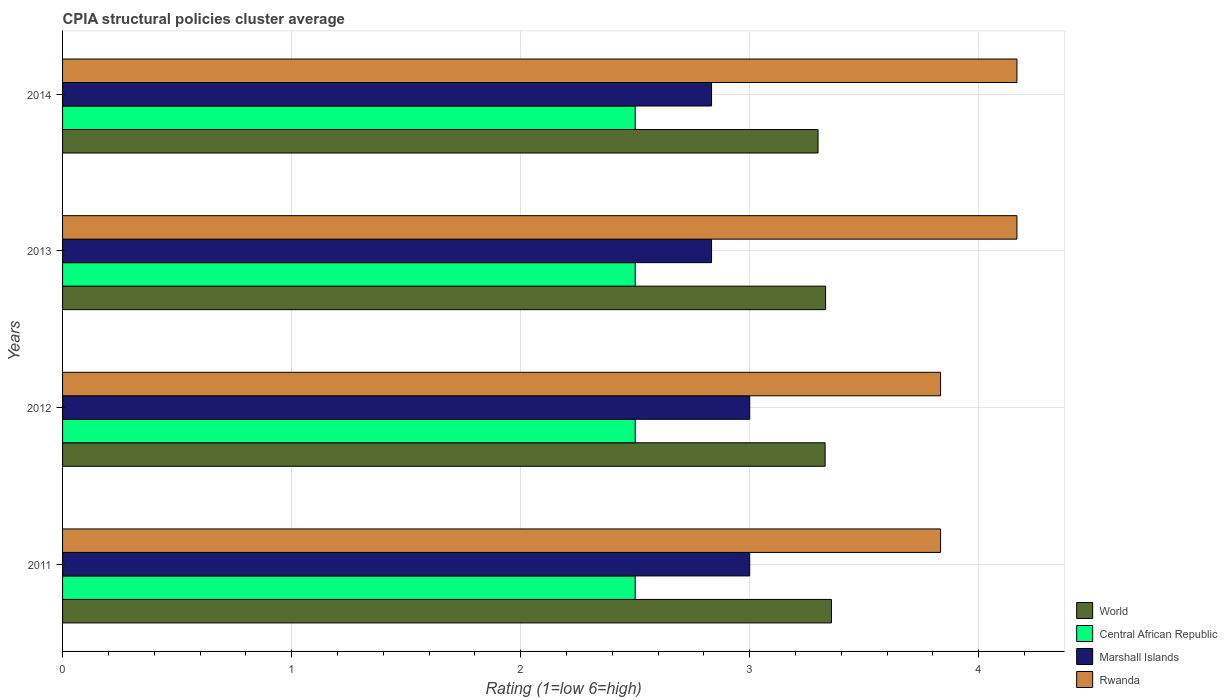How many different coloured bars are there?
Give a very brief answer. 4. How many groups of bars are there?
Offer a very short reply. 4. Are the number of bars per tick equal to the number of legend labels?
Your answer should be compact. Yes. How many bars are there on the 1st tick from the top?
Keep it short and to the point. 4. What is the label of the 3rd group of bars from the top?
Provide a succinct answer. 2012. In how many cases, is the number of bars for a given year not equal to the number of legend labels?
Offer a terse response. 0. What is the CPIA rating in Rwanda in 2012?
Give a very brief answer. 3.83. Across all years, what is the minimum CPIA rating in World?
Keep it short and to the point. 3.3. In which year was the CPIA rating in World maximum?
Your answer should be compact. 2011. What is the total CPIA rating in Central African Republic in the graph?
Your answer should be compact. 10. What is the difference between the CPIA rating in World in 2012 and that in 2014?
Keep it short and to the point. 0.03. What is the difference between the CPIA rating in Rwanda in 2014 and the CPIA rating in Marshall Islands in 2012?
Provide a succinct answer. 1.17. What is the average CPIA rating in World per year?
Your answer should be very brief. 3.33. In the year 2014, what is the difference between the CPIA rating in Rwanda and CPIA rating in Marshall Islands?
Offer a very short reply. 1.33. In how many years, is the CPIA rating in Central African Republic greater than 1.6 ?
Offer a very short reply. 4. What is the ratio of the CPIA rating in World in 2012 to that in 2013?
Ensure brevity in your answer.  1. What is the difference between the highest and the second highest CPIA rating in Marshall Islands?
Offer a terse response. 0. What is the difference between the highest and the lowest CPIA rating in Rwanda?
Offer a very short reply. 0.33. In how many years, is the CPIA rating in Central African Republic greater than the average CPIA rating in Central African Republic taken over all years?
Keep it short and to the point. 0. Is the sum of the CPIA rating in World in 2011 and 2014 greater than the maximum CPIA rating in Central African Republic across all years?
Keep it short and to the point. Yes. Is it the case that in every year, the sum of the CPIA rating in Rwanda and CPIA rating in Central African Republic is greater than the sum of CPIA rating in Marshall Islands and CPIA rating in World?
Make the answer very short. Yes. What does the 2nd bar from the top in 2012 represents?
Provide a succinct answer. Marshall Islands. What does the 2nd bar from the bottom in 2011 represents?
Make the answer very short. Central African Republic. Is it the case that in every year, the sum of the CPIA rating in Marshall Islands and CPIA rating in Rwanda is greater than the CPIA rating in World?
Your answer should be compact. Yes. How many bars are there?
Your response must be concise. 16. How many years are there in the graph?
Provide a succinct answer. 4. What is the difference between two consecutive major ticks on the X-axis?
Offer a terse response. 1. Are the values on the major ticks of X-axis written in scientific E-notation?
Provide a short and direct response. No. Where does the legend appear in the graph?
Your answer should be very brief. Bottom right. How many legend labels are there?
Your response must be concise. 4. How are the legend labels stacked?
Keep it short and to the point. Vertical. What is the title of the graph?
Keep it short and to the point. CPIA structural policies cluster average. What is the label or title of the X-axis?
Make the answer very short. Rating (1=low 6=high). What is the Rating (1=low 6=high) of World in 2011?
Offer a very short reply. 3.36. What is the Rating (1=low 6=high) in Central African Republic in 2011?
Ensure brevity in your answer.  2.5. What is the Rating (1=low 6=high) of Marshall Islands in 2011?
Offer a terse response. 3. What is the Rating (1=low 6=high) in Rwanda in 2011?
Ensure brevity in your answer.  3.83. What is the Rating (1=low 6=high) in World in 2012?
Your answer should be compact. 3.33. What is the Rating (1=low 6=high) in Central African Republic in 2012?
Provide a succinct answer. 2.5. What is the Rating (1=low 6=high) of Rwanda in 2012?
Keep it short and to the point. 3.83. What is the Rating (1=low 6=high) in World in 2013?
Offer a terse response. 3.33. What is the Rating (1=low 6=high) of Central African Republic in 2013?
Offer a very short reply. 2.5. What is the Rating (1=low 6=high) of Marshall Islands in 2013?
Give a very brief answer. 2.83. What is the Rating (1=low 6=high) in Rwanda in 2013?
Ensure brevity in your answer.  4.17. What is the Rating (1=low 6=high) of World in 2014?
Offer a very short reply. 3.3. What is the Rating (1=low 6=high) of Central African Republic in 2014?
Ensure brevity in your answer.  2.5. What is the Rating (1=low 6=high) in Marshall Islands in 2014?
Make the answer very short. 2.83. What is the Rating (1=low 6=high) in Rwanda in 2014?
Offer a very short reply. 4.17. Across all years, what is the maximum Rating (1=low 6=high) in World?
Provide a short and direct response. 3.36. Across all years, what is the maximum Rating (1=low 6=high) in Marshall Islands?
Your answer should be very brief. 3. Across all years, what is the maximum Rating (1=low 6=high) of Rwanda?
Make the answer very short. 4.17. Across all years, what is the minimum Rating (1=low 6=high) in World?
Provide a succinct answer. 3.3. Across all years, what is the minimum Rating (1=low 6=high) of Marshall Islands?
Provide a short and direct response. 2.83. Across all years, what is the minimum Rating (1=low 6=high) in Rwanda?
Make the answer very short. 3.83. What is the total Rating (1=low 6=high) in World in the graph?
Ensure brevity in your answer.  13.32. What is the total Rating (1=low 6=high) of Central African Republic in the graph?
Provide a short and direct response. 10. What is the total Rating (1=low 6=high) of Marshall Islands in the graph?
Keep it short and to the point. 11.67. What is the difference between the Rating (1=low 6=high) in World in 2011 and that in 2012?
Keep it short and to the point. 0.03. What is the difference between the Rating (1=low 6=high) in Marshall Islands in 2011 and that in 2012?
Ensure brevity in your answer.  0. What is the difference between the Rating (1=low 6=high) in Rwanda in 2011 and that in 2012?
Offer a terse response. 0. What is the difference between the Rating (1=low 6=high) in World in 2011 and that in 2013?
Offer a terse response. 0.03. What is the difference between the Rating (1=low 6=high) of Marshall Islands in 2011 and that in 2013?
Your response must be concise. 0.17. What is the difference between the Rating (1=low 6=high) of Rwanda in 2011 and that in 2013?
Give a very brief answer. -0.33. What is the difference between the Rating (1=low 6=high) of World in 2011 and that in 2014?
Keep it short and to the point. 0.06. What is the difference between the Rating (1=low 6=high) of Marshall Islands in 2011 and that in 2014?
Your answer should be very brief. 0.17. What is the difference between the Rating (1=low 6=high) of Rwanda in 2011 and that in 2014?
Provide a succinct answer. -0.33. What is the difference between the Rating (1=low 6=high) of World in 2012 and that in 2013?
Offer a terse response. -0. What is the difference between the Rating (1=low 6=high) of Central African Republic in 2012 and that in 2013?
Your answer should be compact. 0. What is the difference between the Rating (1=low 6=high) of Marshall Islands in 2012 and that in 2013?
Your answer should be compact. 0.17. What is the difference between the Rating (1=low 6=high) of World in 2012 and that in 2014?
Your answer should be very brief. 0.03. What is the difference between the Rating (1=low 6=high) of Marshall Islands in 2012 and that in 2014?
Ensure brevity in your answer.  0.17. What is the difference between the Rating (1=low 6=high) of World in 2013 and that in 2014?
Offer a very short reply. 0.03. What is the difference between the Rating (1=low 6=high) in Rwanda in 2013 and that in 2014?
Keep it short and to the point. -0. What is the difference between the Rating (1=low 6=high) in World in 2011 and the Rating (1=low 6=high) in Central African Republic in 2012?
Offer a terse response. 0.86. What is the difference between the Rating (1=low 6=high) of World in 2011 and the Rating (1=low 6=high) of Marshall Islands in 2012?
Ensure brevity in your answer.  0.36. What is the difference between the Rating (1=low 6=high) in World in 2011 and the Rating (1=low 6=high) in Rwanda in 2012?
Your answer should be very brief. -0.48. What is the difference between the Rating (1=low 6=high) in Central African Republic in 2011 and the Rating (1=low 6=high) in Marshall Islands in 2012?
Offer a terse response. -0.5. What is the difference between the Rating (1=low 6=high) in Central African Republic in 2011 and the Rating (1=low 6=high) in Rwanda in 2012?
Give a very brief answer. -1.33. What is the difference between the Rating (1=low 6=high) in World in 2011 and the Rating (1=low 6=high) in Central African Republic in 2013?
Give a very brief answer. 0.86. What is the difference between the Rating (1=low 6=high) of World in 2011 and the Rating (1=low 6=high) of Marshall Islands in 2013?
Your answer should be very brief. 0.52. What is the difference between the Rating (1=low 6=high) in World in 2011 and the Rating (1=low 6=high) in Rwanda in 2013?
Keep it short and to the point. -0.81. What is the difference between the Rating (1=low 6=high) in Central African Republic in 2011 and the Rating (1=low 6=high) in Rwanda in 2013?
Provide a short and direct response. -1.67. What is the difference between the Rating (1=low 6=high) in Marshall Islands in 2011 and the Rating (1=low 6=high) in Rwanda in 2013?
Ensure brevity in your answer.  -1.17. What is the difference between the Rating (1=low 6=high) in World in 2011 and the Rating (1=low 6=high) in Central African Republic in 2014?
Offer a terse response. 0.86. What is the difference between the Rating (1=low 6=high) of World in 2011 and the Rating (1=low 6=high) of Marshall Islands in 2014?
Make the answer very short. 0.52. What is the difference between the Rating (1=low 6=high) in World in 2011 and the Rating (1=low 6=high) in Rwanda in 2014?
Your response must be concise. -0.81. What is the difference between the Rating (1=low 6=high) of Central African Republic in 2011 and the Rating (1=low 6=high) of Marshall Islands in 2014?
Your response must be concise. -0.33. What is the difference between the Rating (1=low 6=high) of Central African Republic in 2011 and the Rating (1=low 6=high) of Rwanda in 2014?
Offer a terse response. -1.67. What is the difference between the Rating (1=low 6=high) of Marshall Islands in 2011 and the Rating (1=low 6=high) of Rwanda in 2014?
Provide a short and direct response. -1.17. What is the difference between the Rating (1=low 6=high) of World in 2012 and the Rating (1=low 6=high) of Central African Republic in 2013?
Keep it short and to the point. 0.83. What is the difference between the Rating (1=low 6=high) in World in 2012 and the Rating (1=low 6=high) in Marshall Islands in 2013?
Your response must be concise. 0.5. What is the difference between the Rating (1=low 6=high) of World in 2012 and the Rating (1=low 6=high) of Rwanda in 2013?
Keep it short and to the point. -0.84. What is the difference between the Rating (1=low 6=high) in Central African Republic in 2012 and the Rating (1=low 6=high) in Marshall Islands in 2013?
Make the answer very short. -0.33. What is the difference between the Rating (1=low 6=high) in Central African Republic in 2012 and the Rating (1=low 6=high) in Rwanda in 2013?
Keep it short and to the point. -1.67. What is the difference between the Rating (1=low 6=high) of Marshall Islands in 2012 and the Rating (1=low 6=high) of Rwanda in 2013?
Offer a terse response. -1.17. What is the difference between the Rating (1=low 6=high) of World in 2012 and the Rating (1=low 6=high) of Central African Republic in 2014?
Keep it short and to the point. 0.83. What is the difference between the Rating (1=low 6=high) of World in 2012 and the Rating (1=low 6=high) of Marshall Islands in 2014?
Your response must be concise. 0.5. What is the difference between the Rating (1=low 6=high) in World in 2012 and the Rating (1=low 6=high) in Rwanda in 2014?
Your response must be concise. -0.84. What is the difference between the Rating (1=low 6=high) of Central African Republic in 2012 and the Rating (1=low 6=high) of Rwanda in 2014?
Offer a terse response. -1.67. What is the difference between the Rating (1=low 6=high) of Marshall Islands in 2012 and the Rating (1=low 6=high) of Rwanda in 2014?
Your answer should be very brief. -1.17. What is the difference between the Rating (1=low 6=high) of World in 2013 and the Rating (1=low 6=high) of Central African Republic in 2014?
Ensure brevity in your answer.  0.83. What is the difference between the Rating (1=low 6=high) in World in 2013 and the Rating (1=low 6=high) in Marshall Islands in 2014?
Provide a short and direct response. 0.5. What is the difference between the Rating (1=low 6=high) of World in 2013 and the Rating (1=low 6=high) of Rwanda in 2014?
Your response must be concise. -0.84. What is the difference between the Rating (1=low 6=high) of Central African Republic in 2013 and the Rating (1=low 6=high) of Rwanda in 2014?
Your response must be concise. -1.67. What is the difference between the Rating (1=low 6=high) in Marshall Islands in 2013 and the Rating (1=low 6=high) in Rwanda in 2014?
Ensure brevity in your answer.  -1.33. What is the average Rating (1=low 6=high) of World per year?
Keep it short and to the point. 3.33. What is the average Rating (1=low 6=high) of Marshall Islands per year?
Your response must be concise. 2.92. In the year 2011, what is the difference between the Rating (1=low 6=high) of World and Rating (1=low 6=high) of Central African Republic?
Offer a terse response. 0.86. In the year 2011, what is the difference between the Rating (1=low 6=high) in World and Rating (1=low 6=high) in Marshall Islands?
Offer a very short reply. 0.36. In the year 2011, what is the difference between the Rating (1=low 6=high) of World and Rating (1=low 6=high) of Rwanda?
Offer a very short reply. -0.48. In the year 2011, what is the difference between the Rating (1=low 6=high) in Central African Republic and Rating (1=low 6=high) in Rwanda?
Make the answer very short. -1.33. In the year 2012, what is the difference between the Rating (1=low 6=high) in World and Rating (1=low 6=high) in Central African Republic?
Offer a terse response. 0.83. In the year 2012, what is the difference between the Rating (1=low 6=high) in World and Rating (1=low 6=high) in Marshall Islands?
Your answer should be very brief. 0.33. In the year 2012, what is the difference between the Rating (1=low 6=high) in World and Rating (1=low 6=high) in Rwanda?
Provide a succinct answer. -0.5. In the year 2012, what is the difference between the Rating (1=low 6=high) of Central African Republic and Rating (1=low 6=high) of Marshall Islands?
Offer a terse response. -0.5. In the year 2012, what is the difference between the Rating (1=low 6=high) in Central African Republic and Rating (1=low 6=high) in Rwanda?
Your response must be concise. -1.33. In the year 2013, what is the difference between the Rating (1=low 6=high) in World and Rating (1=low 6=high) in Central African Republic?
Keep it short and to the point. 0.83. In the year 2013, what is the difference between the Rating (1=low 6=high) in World and Rating (1=low 6=high) in Marshall Islands?
Provide a succinct answer. 0.5. In the year 2013, what is the difference between the Rating (1=low 6=high) in World and Rating (1=low 6=high) in Rwanda?
Provide a succinct answer. -0.84. In the year 2013, what is the difference between the Rating (1=low 6=high) in Central African Republic and Rating (1=low 6=high) in Marshall Islands?
Provide a succinct answer. -0.33. In the year 2013, what is the difference between the Rating (1=low 6=high) in Central African Republic and Rating (1=low 6=high) in Rwanda?
Ensure brevity in your answer.  -1.67. In the year 2013, what is the difference between the Rating (1=low 6=high) of Marshall Islands and Rating (1=low 6=high) of Rwanda?
Your answer should be very brief. -1.33. In the year 2014, what is the difference between the Rating (1=low 6=high) of World and Rating (1=low 6=high) of Central African Republic?
Provide a succinct answer. 0.8. In the year 2014, what is the difference between the Rating (1=low 6=high) of World and Rating (1=low 6=high) of Marshall Islands?
Your answer should be compact. 0.46. In the year 2014, what is the difference between the Rating (1=low 6=high) in World and Rating (1=low 6=high) in Rwanda?
Give a very brief answer. -0.87. In the year 2014, what is the difference between the Rating (1=low 6=high) of Central African Republic and Rating (1=low 6=high) of Marshall Islands?
Make the answer very short. -0.33. In the year 2014, what is the difference between the Rating (1=low 6=high) in Central African Republic and Rating (1=low 6=high) in Rwanda?
Provide a succinct answer. -1.67. In the year 2014, what is the difference between the Rating (1=low 6=high) of Marshall Islands and Rating (1=low 6=high) of Rwanda?
Offer a very short reply. -1.33. What is the ratio of the Rating (1=low 6=high) in World in 2011 to that in 2012?
Provide a short and direct response. 1.01. What is the ratio of the Rating (1=low 6=high) of World in 2011 to that in 2013?
Ensure brevity in your answer.  1.01. What is the ratio of the Rating (1=low 6=high) in Marshall Islands in 2011 to that in 2013?
Offer a terse response. 1.06. What is the ratio of the Rating (1=low 6=high) of World in 2011 to that in 2014?
Ensure brevity in your answer.  1.02. What is the ratio of the Rating (1=low 6=high) of Central African Republic in 2011 to that in 2014?
Provide a short and direct response. 1. What is the ratio of the Rating (1=low 6=high) in Marshall Islands in 2011 to that in 2014?
Offer a very short reply. 1.06. What is the ratio of the Rating (1=low 6=high) in Marshall Islands in 2012 to that in 2013?
Offer a very short reply. 1.06. What is the ratio of the Rating (1=low 6=high) of Rwanda in 2012 to that in 2013?
Your answer should be very brief. 0.92. What is the ratio of the Rating (1=low 6=high) in World in 2012 to that in 2014?
Provide a succinct answer. 1.01. What is the ratio of the Rating (1=low 6=high) of Central African Republic in 2012 to that in 2014?
Offer a terse response. 1. What is the ratio of the Rating (1=low 6=high) in Marshall Islands in 2012 to that in 2014?
Your response must be concise. 1.06. What is the ratio of the Rating (1=low 6=high) of Rwanda in 2012 to that in 2014?
Make the answer very short. 0.92. What is the ratio of the Rating (1=low 6=high) in Rwanda in 2013 to that in 2014?
Your response must be concise. 1. What is the difference between the highest and the second highest Rating (1=low 6=high) in World?
Your answer should be compact. 0.03. What is the difference between the highest and the second highest Rating (1=low 6=high) in Central African Republic?
Your response must be concise. 0. What is the difference between the highest and the second highest Rating (1=low 6=high) of Marshall Islands?
Offer a very short reply. 0. What is the difference between the highest and the second highest Rating (1=low 6=high) of Rwanda?
Offer a very short reply. 0. What is the difference between the highest and the lowest Rating (1=low 6=high) in World?
Provide a short and direct response. 0.06. What is the difference between the highest and the lowest Rating (1=low 6=high) in Rwanda?
Your response must be concise. 0.33. 